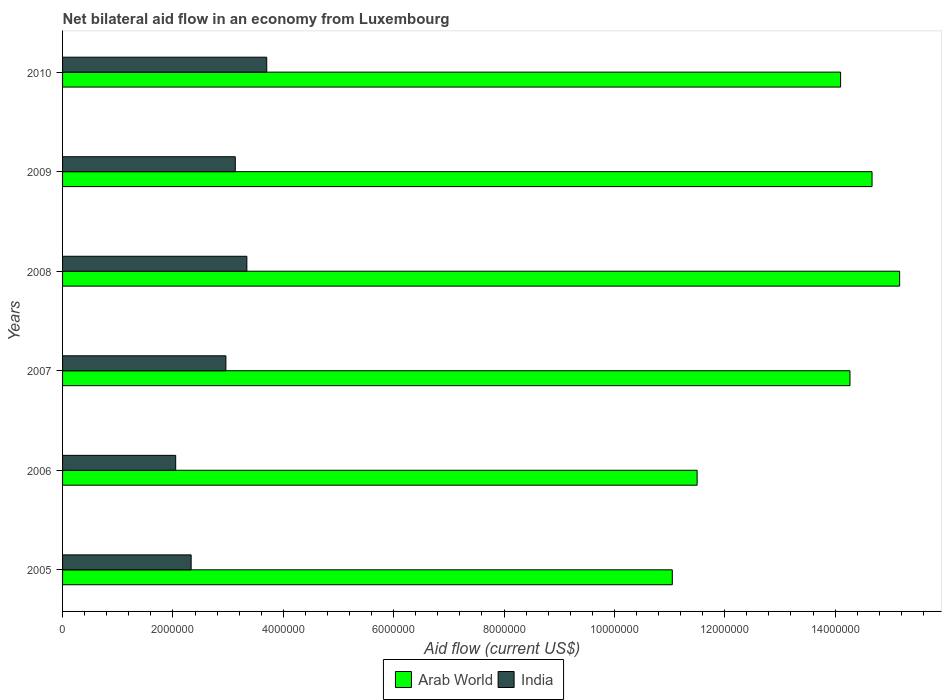How many different coloured bars are there?
Ensure brevity in your answer.  2. How many bars are there on the 6th tick from the top?
Your answer should be compact. 2. What is the label of the 1st group of bars from the top?
Your answer should be very brief. 2010. What is the net bilateral aid flow in Arab World in 2008?
Your answer should be very brief. 1.52e+07. Across all years, what is the maximum net bilateral aid flow in India?
Your answer should be very brief. 3.70e+06. Across all years, what is the minimum net bilateral aid flow in Arab World?
Your answer should be very brief. 1.10e+07. In which year was the net bilateral aid flow in Arab World minimum?
Offer a terse response. 2005. What is the total net bilateral aid flow in Arab World in the graph?
Ensure brevity in your answer.  8.08e+07. What is the difference between the net bilateral aid flow in Arab World in 2006 and that in 2008?
Offer a terse response. -3.67e+06. What is the difference between the net bilateral aid flow in India in 2006 and the net bilateral aid flow in Arab World in 2009?
Offer a terse response. -1.26e+07. What is the average net bilateral aid flow in India per year?
Provide a succinct answer. 2.92e+06. In the year 2006, what is the difference between the net bilateral aid flow in India and net bilateral aid flow in Arab World?
Provide a succinct answer. -9.45e+06. In how many years, is the net bilateral aid flow in India greater than 12000000 US$?
Make the answer very short. 0. What is the ratio of the net bilateral aid flow in India in 2005 to that in 2006?
Offer a very short reply. 1.14. What is the difference between the highest and the second highest net bilateral aid flow in India?
Your response must be concise. 3.60e+05. What is the difference between the highest and the lowest net bilateral aid flow in Arab World?
Give a very brief answer. 4.12e+06. Is the sum of the net bilateral aid flow in Arab World in 2005 and 2006 greater than the maximum net bilateral aid flow in India across all years?
Your answer should be very brief. Yes. What does the 2nd bar from the top in 2008 represents?
Keep it short and to the point. Arab World. What does the 2nd bar from the bottom in 2006 represents?
Provide a short and direct response. India. Are the values on the major ticks of X-axis written in scientific E-notation?
Offer a terse response. No. Does the graph contain any zero values?
Provide a succinct answer. No. Does the graph contain grids?
Offer a very short reply. No. Where does the legend appear in the graph?
Make the answer very short. Bottom center. How are the legend labels stacked?
Provide a short and direct response. Horizontal. What is the title of the graph?
Make the answer very short. Net bilateral aid flow in an economy from Luxembourg. Does "China" appear as one of the legend labels in the graph?
Make the answer very short. No. What is the label or title of the X-axis?
Provide a succinct answer. Aid flow (current US$). What is the label or title of the Y-axis?
Keep it short and to the point. Years. What is the Aid flow (current US$) of Arab World in 2005?
Offer a very short reply. 1.10e+07. What is the Aid flow (current US$) in India in 2005?
Provide a succinct answer. 2.33e+06. What is the Aid flow (current US$) in Arab World in 2006?
Offer a terse response. 1.15e+07. What is the Aid flow (current US$) in India in 2006?
Your answer should be compact. 2.05e+06. What is the Aid flow (current US$) in Arab World in 2007?
Ensure brevity in your answer.  1.43e+07. What is the Aid flow (current US$) of India in 2007?
Your response must be concise. 2.96e+06. What is the Aid flow (current US$) in Arab World in 2008?
Make the answer very short. 1.52e+07. What is the Aid flow (current US$) in India in 2008?
Offer a very short reply. 3.34e+06. What is the Aid flow (current US$) of Arab World in 2009?
Offer a very short reply. 1.47e+07. What is the Aid flow (current US$) in India in 2009?
Provide a succinct answer. 3.13e+06. What is the Aid flow (current US$) of Arab World in 2010?
Keep it short and to the point. 1.41e+07. What is the Aid flow (current US$) in India in 2010?
Make the answer very short. 3.70e+06. Across all years, what is the maximum Aid flow (current US$) of Arab World?
Your answer should be very brief. 1.52e+07. Across all years, what is the maximum Aid flow (current US$) in India?
Offer a terse response. 3.70e+06. Across all years, what is the minimum Aid flow (current US$) in Arab World?
Make the answer very short. 1.10e+07. Across all years, what is the minimum Aid flow (current US$) in India?
Your answer should be very brief. 2.05e+06. What is the total Aid flow (current US$) in Arab World in the graph?
Provide a succinct answer. 8.08e+07. What is the total Aid flow (current US$) of India in the graph?
Your answer should be compact. 1.75e+07. What is the difference between the Aid flow (current US$) in Arab World in 2005 and that in 2006?
Provide a succinct answer. -4.50e+05. What is the difference between the Aid flow (current US$) of Arab World in 2005 and that in 2007?
Give a very brief answer. -3.22e+06. What is the difference between the Aid flow (current US$) of India in 2005 and that in 2007?
Your answer should be compact. -6.30e+05. What is the difference between the Aid flow (current US$) of Arab World in 2005 and that in 2008?
Keep it short and to the point. -4.12e+06. What is the difference between the Aid flow (current US$) of India in 2005 and that in 2008?
Keep it short and to the point. -1.01e+06. What is the difference between the Aid flow (current US$) in Arab World in 2005 and that in 2009?
Provide a short and direct response. -3.62e+06. What is the difference between the Aid flow (current US$) of India in 2005 and that in 2009?
Your response must be concise. -8.00e+05. What is the difference between the Aid flow (current US$) of Arab World in 2005 and that in 2010?
Give a very brief answer. -3.05e+06. What is the difference between the Aid flow (current US$) in India in 2005 and that in 2010?
Keep it short and to the point. -1.37e+06. What is the difference between the Aid flow (current US$) of Arab World in 2006 and that in 2007?
Offer a very short reply. -2.77e+06. What is the difference between the Aid flow (current US$) of India in 2006 and that in 2007?
Keep it short and to the point. -9.10e+05. What is the difference between the Aid flow (current US$) in Arab World in 2006 and that in 2008?
Your answer should be very brief. -3.67e+06. What is the difference between the Aid flow (current US$) of India in 2006 and that in 2008?
Your response must be concise. -1.29e+06. What is the difference between the Aid flow (current US$) of Arab World in 2006 and that in 2009?
Keep it short and to the point. -3.17e+06. What is the difference between the Aid flow (current US$) in India in 2006 and that in 2009?
Make the answer very short. -1.08e+06. What is the difference between the Aid flow (current US$) in Arab World in 2006 and that in 2010?
Make the answer very short. -2.60e+06. What is the difference between the Aid flow (current US$) in India in 2006 and that in 2010?
Your answer should be compact. -1.65e+06. What is the difference between the Aid flow (current US$) in Arab World in 2007 and that in 2008?
Keep it short and to the point. -9.00e+05. What is the difference between the Aid flow (current US$) in India in 2007 and that in 2008?
Provide a succinct answer. -3.80e+05. What is the difference between the Aid flow (current US$) in Arab World in 2007 and that in 2009?
Give a very brief answer. -4.00e+05. What is the difference between the Aid flow (current US$) of Arab World in 2007 and that in 2010?
Your answer should be very brief. 1.70e+05. What is the difference between the Aid flow (current US$) in India in 2007 and that in 2010?
Your response must be concise. -7.40e+05. What is the difference between the Aid flow (current US$) of Arab World in 2008 and that in 2010?
Ensure brevity in your answer.  1.07e+06. What is the difference between the Aid flow (current US$) of India in 2008 and that in 2010?
Provide a short and direct response. -3.60e+05. What is the difference between the Aid flow (current US$) of Arab World in 2009 and that in 2010?
Offer a very short reply. 5.70e+05. What is the difference between the Aid flow (current US$) in India in 2009 and that in 2010?
Offer a very short reply. -5.70e+05. What is the difference between the Aid flow (current US$) in Arab World in 2005 and the Aid flow (current US$) in India in 2006?
Provide a succinct answer. 9.00e+06. What is the difference between the Aid flow (current US$) in Arab World in 2005 and the Aid flow (current US$) in India in 2007?
Make the answer very short. 8.09e+06. What is the difference between the Aid flow (current US$) of Arab World in 2005 and the Aid flow (current US$) of India in 2008?
Your answer should be very brief. 7.71e+06. What is the difference between the Aid flow (current US$) of Arab World in 2005 and the Aid flow (current US$) of India in 2009?
Ensure brevity in your answer.  7.92e+06. What is the difference between the Aid flow (current US$) in Arab World in 2005 and the Aid flow (current US$) in India in 2010?
Ensure brevity in your answer.  7.35e+06. What is the difference between the Aid flow (current US$) in Arab World in 2006 and the Aid flow (current US$) in India in 2007?
Your answer should be compact. 8.54e+06. What is the difference between the Aid flow (current US$) in Arab World in 2006 and the Aid flow (current US$) in India in 2008?
Offer a very short reply. 8.16e+06. What is the difference between the Aid flow (current US$) of Arab World in 2006 and the Aid flow (current US$) of India in 2009?
Your answer should be compact. 8.37e+06. What is the difference between the Aid flow (current US$) in Arab World in 2006 and the Aid flow (current US$) in India in 2010?
Make the answer very short. 7.80e+06. What is the difference between the Aid flow (current US$) in Arab World in 2007 and the Aid flow (current US$) in India in 2008?
Give a very brief answer. 1.09e+07. What is the difference between the Aid flow (current US$) in Arab World in 2007 and the Aid flow (current US$) in India in 2009?
Your answer should be compact. 1.11e+07. What is the difference between the Aid flow (current US$) of Arab World in 2007 and the Aid flow (current US$) of India in 2010?
Offer a terse response. 1.06e+07. What is the difference between the Aid flow (current US$) in Arab World in 2008 and the Aid flow (current US$) in India in 2009?
Your response must be concise. 1.20e+07. What is the difference between the Aid flow (current US$) in Arab World in 2008 and the Aid flow (current US$) in India in 2010?
Keep it short and to the point. 1.15e+07. What is the difference between the Aid flow (current US$) of Arab World in 2009 and the Aid flow (current US$) of India in 2010?
Provide a short and direct response. 1.10e+07. What is the average Aid flow (current US$) of Arab World per year?
Offer a very short reply. 1.35e+07. What is the average Aid flow (current US$) of India per year?
Your answer should be compact. 2.92e+06. In the year 2005, what is the difference between the Aid flow (current US$) of Arab World and Aid flow (current US$) of India?
Your answer should be compact. 8.72e+06. In the year 2006, what is the difference between the Aid flow (current US$) of Arab World and Aid flow (current US$) of India?
Provide a succinct answer. 9.45e+06. In the year 2007, what is the difference between the Aid flow (current US$) of Arab World and Aid flow (current US$) of India?
Ensure brevity in your answer.  1.13e+07. In the year 2008, what is the difference between the Aid flow (current US$) of Arab World and Aid flow (current US$) of India?
Provide a succinct answer. 1.18e+07. In the year 2009, what is the difference between the Aid flow (current US$) of Arab World and Aid flow (current US$) of India?
Your answer should be compact. 1.15e+07. In the year 2010, what is the difference between the Aid flow (current US$) of Arab World and Aid flow (current US$) of India?
Keep it short and to the point. 1.04e+07. What is the ratio of the Aid flow (current US$) of Arab World in 2005 to that in 2006?
Offer a very short reply. 0.96. What is the ratio of the Aid flow (current US$) of India in 2005 to that in 2006?
Make the answer very short. 1.14. What is the ratio of the Aid flow (current US$) in Arab World in 2005 to that in 2007?
Your response must be concise. 0.77. What is the ratio of the Aid flow (current US$) in India in 2005 to that in 2007?
Provide a short and direct response. 0.79. What is the ratio of the Aid flow (current US$) in Arab World in 2005 to that in 2008?
Keep it short and to the point. 0.73. What is the ratio of the Aid flow (current US$) of India in 2005 to that in 2008?
Provide a succinct answer. 0.7. What is the ratio of the Aid flow (current US$) in Arab World in 2005 to that in 2009?
Ensure brevity in your answer.  0.75. What is the ratio of the Aid flow (current US$) of India in 2005 to that in 2009?
Keep it short and to the point. 0.74. What is the ratio of the Aid flow (current US$) in Arab World in 2005 to that in 2010?
Provide a succinct answer. 0.78. What is the ratio of the Aid flow (current US$) of India in 2005 to that in 2010?
Offer a very short reply. 0.63. What is the ratio of the Aid flow (current US$) of Arab World in 2006 to that in 2007?
Provide a succinct answer. 0.81. What is the ratio of the Aid flow (current US$) of India in 2006 to that in 2007?
Provide a succinct answer. 0.69. What is the ratio of the Aid flow (current US$) of Arab World in 2006 to that in 2008?
Give a very brief answer. 0.76. What is the ratio of the Aid flow (current US$) of India in 2006 to that in 2008?
Your response must be concise. 0.61. What is the ratio of the Aid flow (current US$) of Arab World in 2006 to that in 2009?
Your answer should be compact. 0.78. What is the ratio of the Aid flow (current US$) in India in 2006 to that in 2009?
Keep it short and to the point. 0.66. What is the ratio of the Aid flow (current US$) of Arab World in 2006 to that in 2010?
Give a very brief answer. 0.82. What is the ratio of the Aid flow (current US$) of India in 2006 to that in 2010?
Offer a very short reply. 0.55. What is the ratio of the Aid flow (current US$) of Arab World in 2007 to that in 2008?
Your answer should be compact. 0.94. What is the ratio of the Aid flow (current US$) in India in 2007 to that in 2008?
Offer a terse response. 0.89. What is the ratio of the Aid flow (current US$) of Arab World in 2007 to that in 2009?
Your answer should be compact. 0.97. What is the ratio of the Aid flow (current US$) of India in 2007 to that in 2009?
Ensure brevity in your answer.  0.95. What is the ratio of the Aid flow (current US$) of Arab World in 2007 to that in 2010?
Ensure brevity in your answer.  1.01. What is the ratio of the Aid flow (current US$) of Arab World in 2008 to that in 2009?
Offer a very short reply. 1.03. What is the ratio of the Aid flow (current US$) in India in 2008 to that in 2009?
Give a very brief answer. 1.07. What is the ratio of the Aid flow (current US$) in Arab World in 2008 to that in 2010?
Provide a short and direct response. 1.08. What is the ratio of the Aid flow (current US$) of India in 2008 to that in 2010?
Your answer should be compact. 0.9. What is the ratio of the Aid flow (current US$) in Arab World in 2009 to that in 2010?
Provide a succinct answer. 1.04. What is the ratio of the Aid flow (current US$) in India in 2009 to that in 2010?
Make the answer very short. 0.85. What is the difference between the highest and the second highest Aid flow (current US$) of Arab World?
Your answer should be very brief. 5.00e+05. What is the difference between the highest and the lowest Aid flow (current US$) of Arab World?
Make the answer very short. 4.12e+06. What is the difference between the highest and the lowest Aid flow (current US$) of India?
Provide a succinct answer. 1.65e+06. 